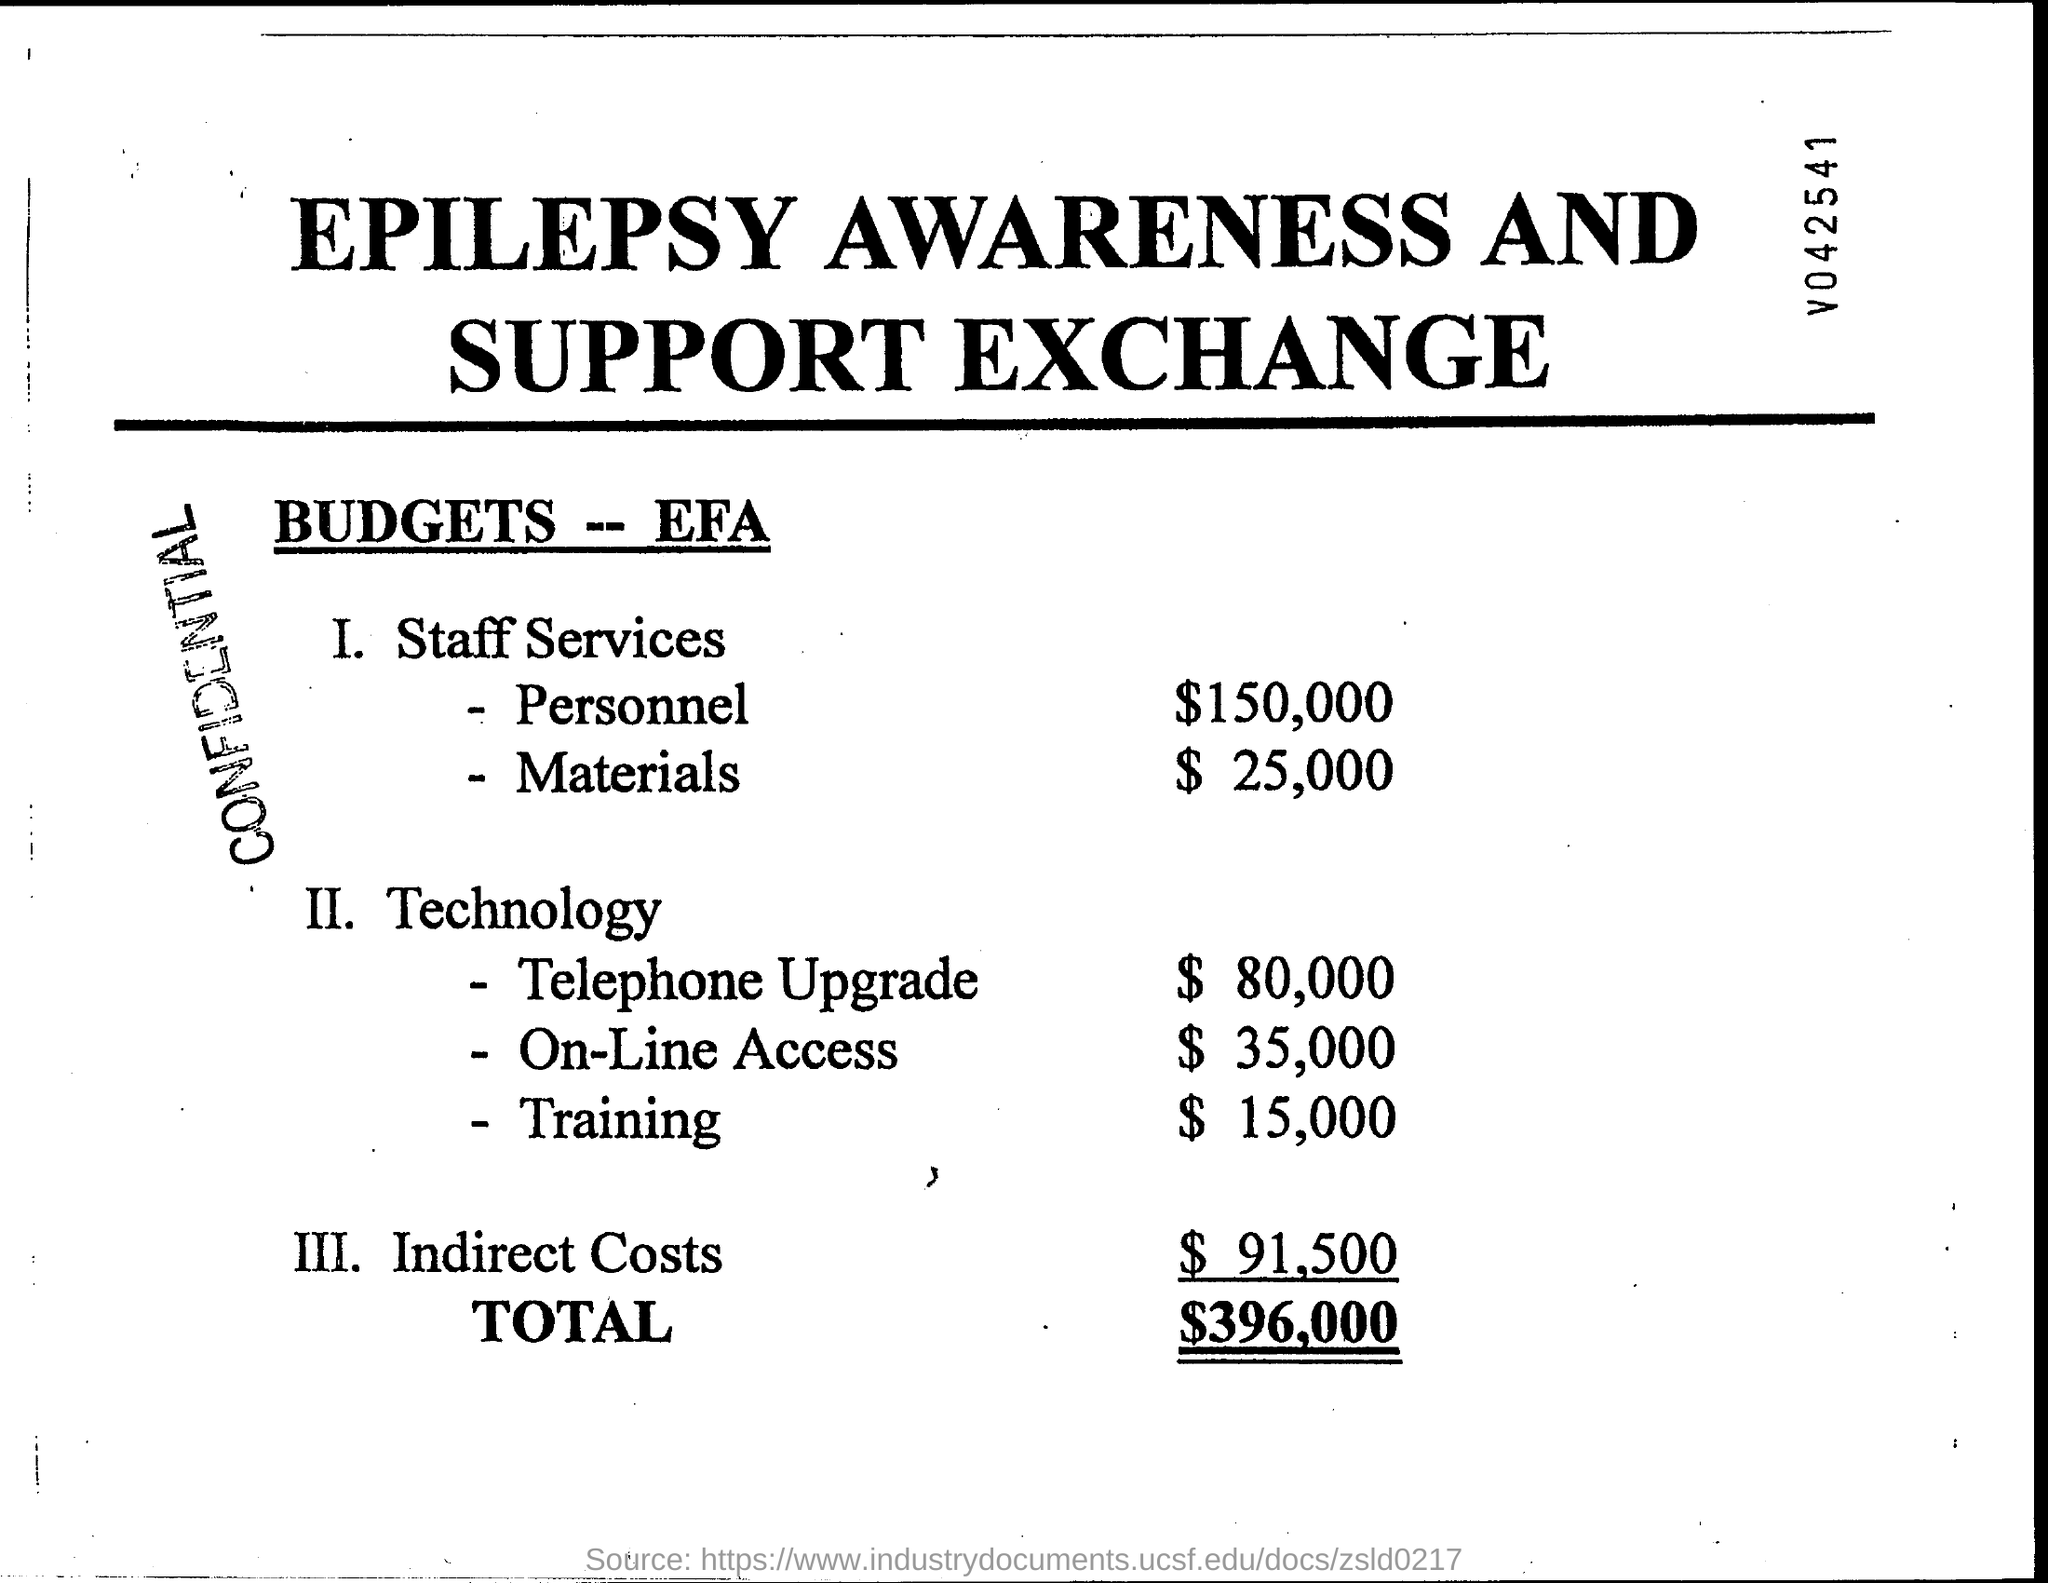Indicate a few pertinent items in this graphic. The document has a stamp that reads 'confidential.' 